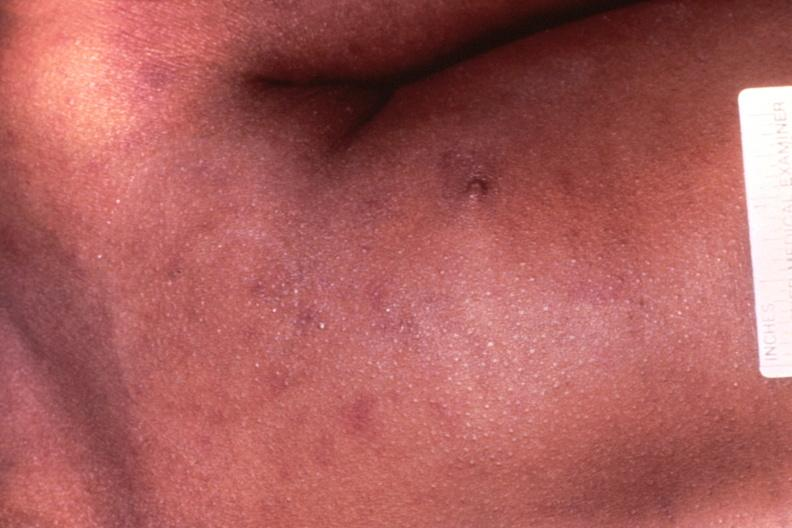where is this?
Answer the question using a single word or phrase. Skin 